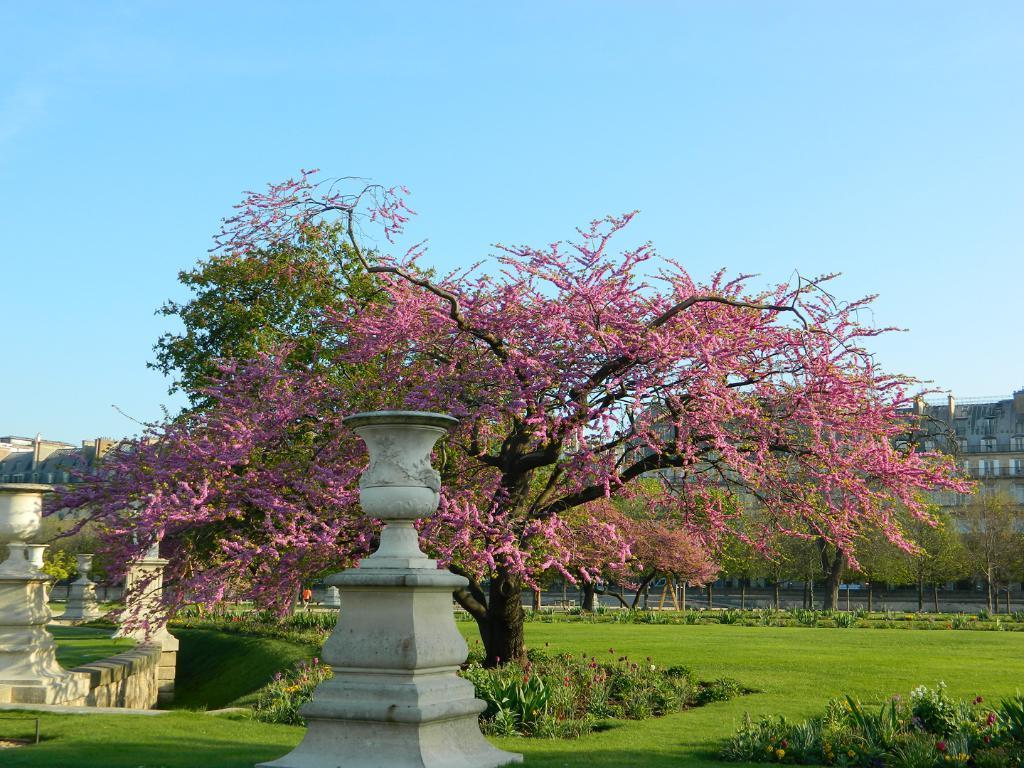Please provide a concise description of this image. In this image we can see a garden. In garden so many plants are present and trees are there. Left side of the image pillars are there. Background one building is there. The sky is in blue color. 